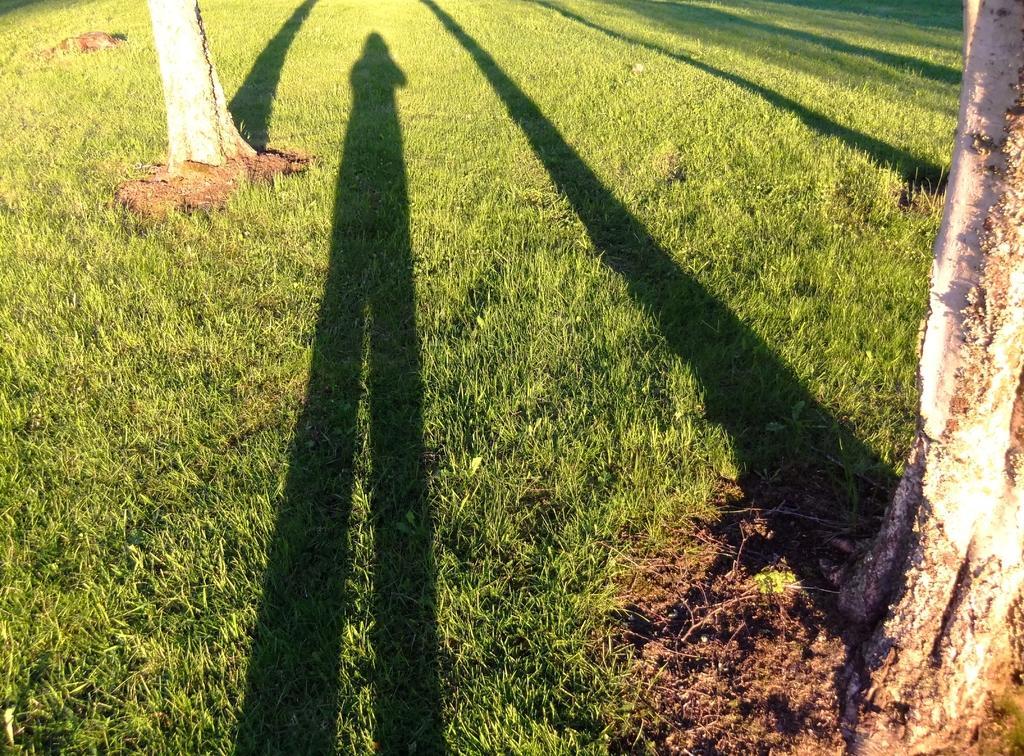How would you summarize this image in a sentence or two? In the foreground of the picture there are trees, red soil, grass and shadows. At the top there is grass. 